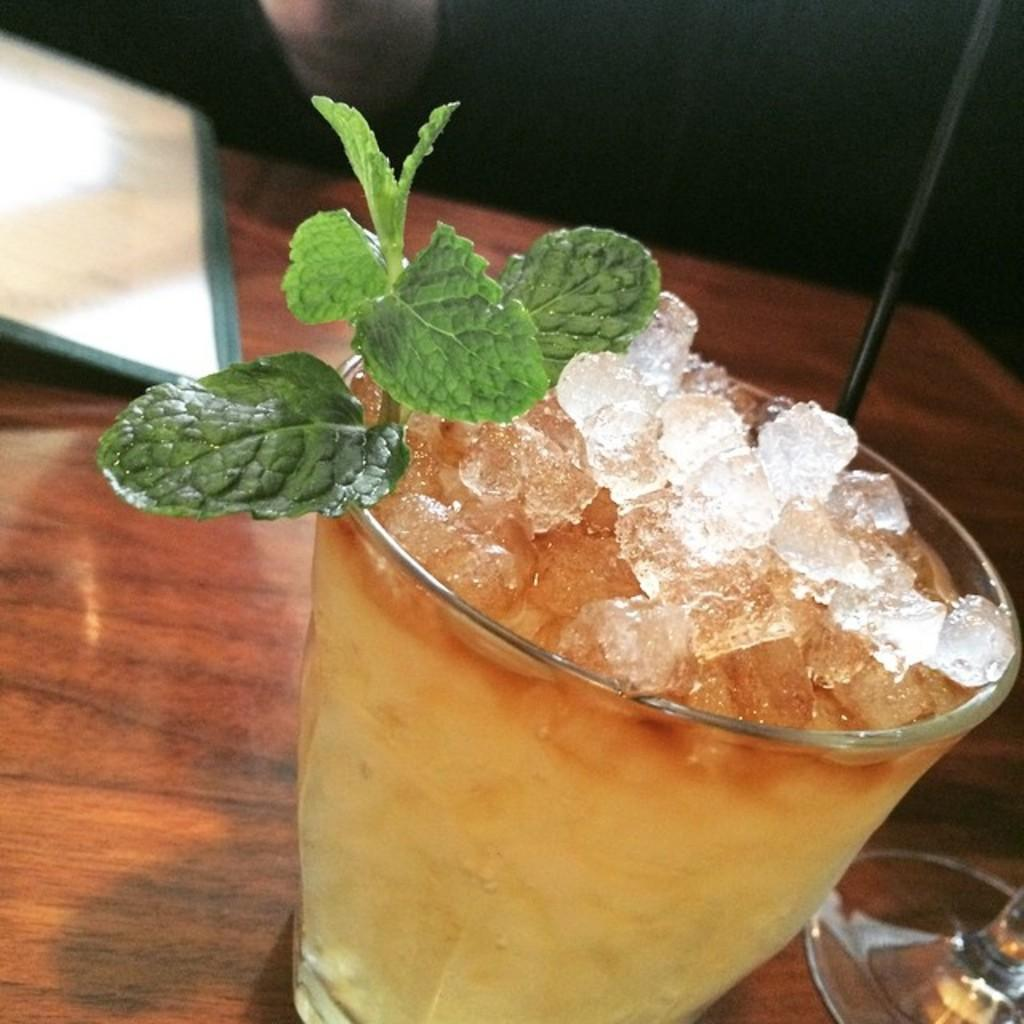What is inside the glass that is visible in the image? There is a glass with ice and leaves in it. What else can be seen on the table in the image? There are objects on the table. How would you describe the lighting in the image? The background of the image is dark. How many bikes are visible in the yard in the image? There are no bikes or yards present in the image; it only shows a glass with ice and leaves on a table with a dark background. 